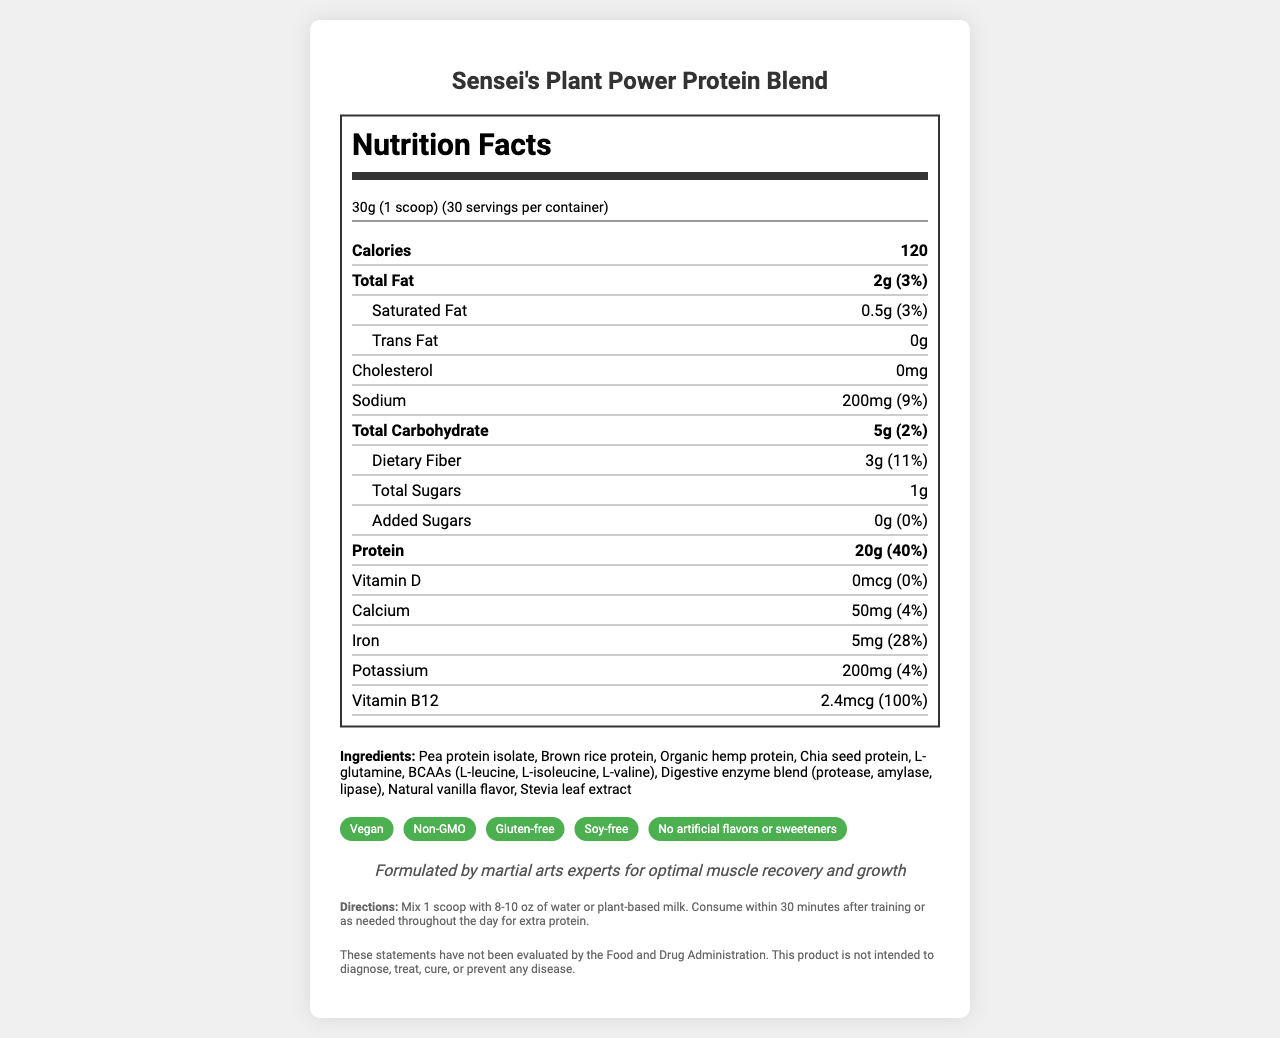what is the serving size of Sensei's Plant Power Protein Blend? The serving size is listed as "30g (1 scoop)" in the nutrition facts section of the document.
Answer: 30g (1 scoop) how many calories are in one serving? The document specifies that there are 120 calories per serving.
Answer: 120 calories who formulated Sensei's Plant Power Protein Blend? The brand statement mentions that the product is formulated by martial arts experts for optimal muscle recovery and growth.
Answer: Martial arts experts which ingredient is not included in Sensei's Plant Power Protein Blend? A. Pea protein isolate B. Whey protein C. Chia seed protein D. Organic hemp protein The list of ingredients includes Pea protein isolate, Chia seed protein, and Organic hemp protein, but does not mention Whey protein.
Answer: B how much protein is in one serving? The document states that there are 20 grams of protein per serving.
Answer: 20g what is the daily value percentage of iron in the product? The document notes that the product provides 5mg of iron per serving, which is 28% of the daily value.
Answer: 28% describe the allergens information included for this product The document includes a specific note stating that the product is manufactured in a facility that also processes soy and tree nuts.
Answer: Manufactured in a facility that also processes soy and tree nuts. which of the following is a marketing claim made about the product? A. Contains dairy B. Gluten-free C. Contains artificial sweeteners One of the marketing claims listed is "Gluten-free."
Answer: B are there any added sugars in the product? The added sugars amount is listed as 0g with a daily value of 0%.
Answer: No list three sources of protein in the blend These three protein sources are included in the ingredients list.
Answer: Pea protein isolate, Brown rice protein, and Organic hemp protein is this product likely suitable for vegans? The marketing claims include "Vegan," indicating the product is suitable for vegans.
Answer: Yes what amount of vitamin B12 is provided per serving? The document states that each serving contains 2.4mcg of vitamin B12.
Answer: 2.4mcg when should you consume this protein blend according to the directions? The directions specify the ideal consumption times for the protein blend.
Answer: Within 30 minutes after training or as needed throughout the day for extra protein. explain the main purpose of this document The document includes the nutrition facts, ingredients, serving suggestions, and marketing claims to inform potential buyers about the product's benefits and appropriate use.
Answer: The document provides detailed nutritional information and marketing claims of Sensei's Plant Power Protein Blend, emphasizing its benefits for muscle recovery and growth, particularly designed by martial arts experts. do we know the product's price from this document? There is no information regarding the price of the product in the document.
Answer: Cannot be determined 